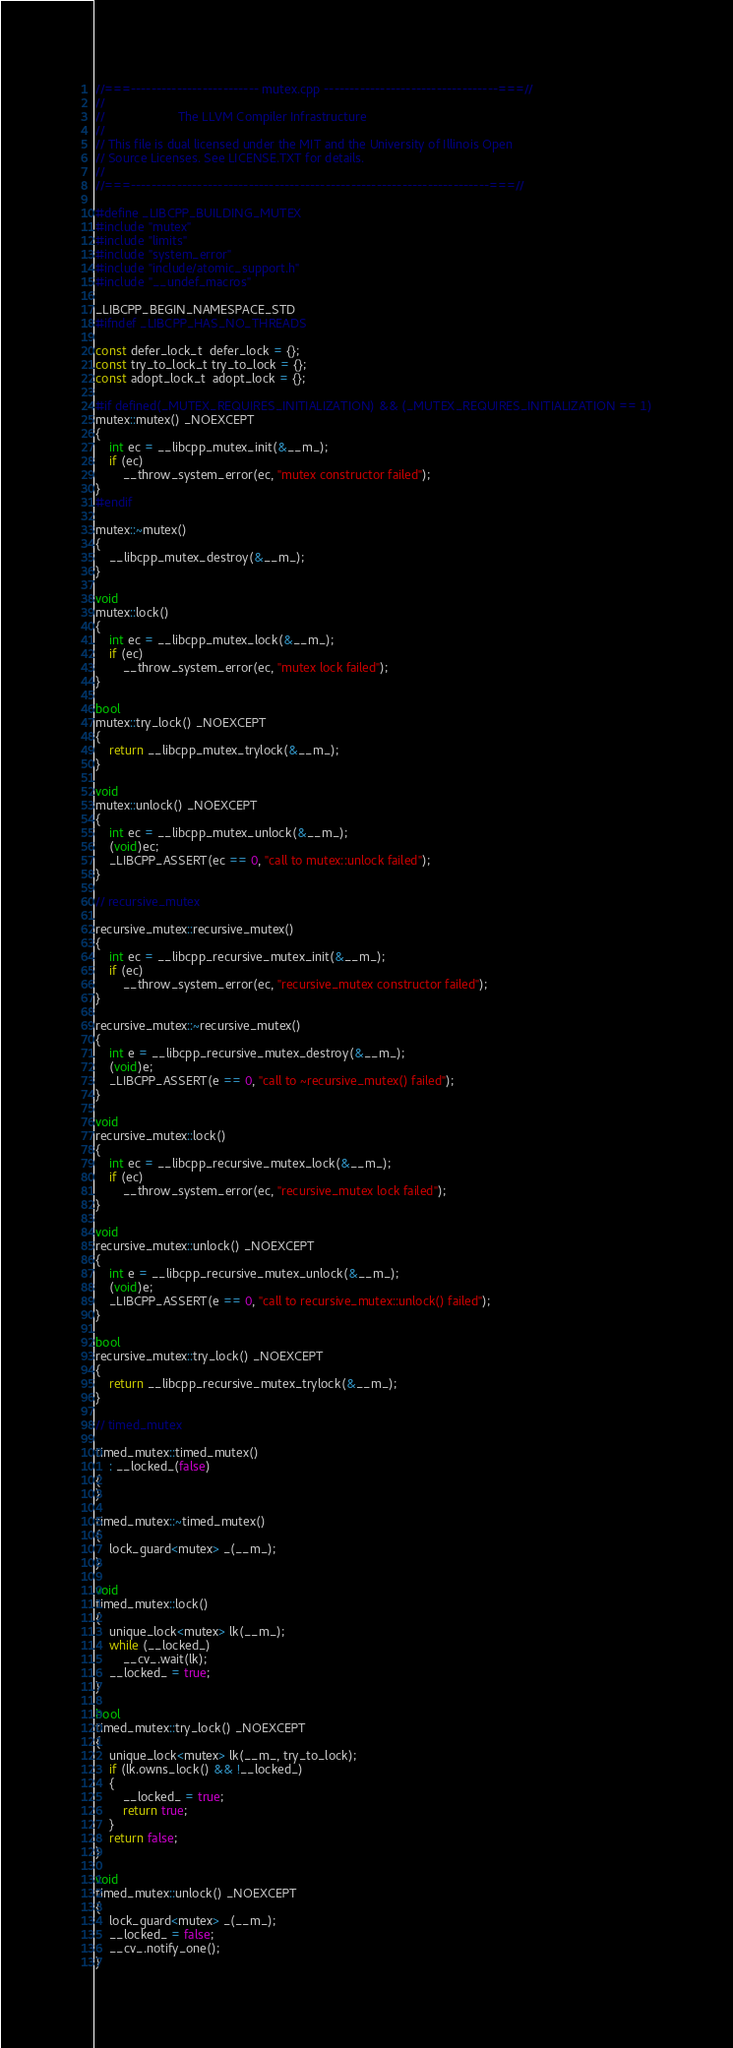<code> <loc_0><loc_0><loc_500><loc_500><_C++_>//===------------------------- mutex.cpp ----------------------------------===//
//
//                     The LLVM Compiler Infrastructure
//
// This file is dual licensed under the MIT and the University of Illinois Open
// Source Licenses. See LICENSE.TXT for details.
//
//===----------------------------------------------------------------------===//

#define _LIBCPP_BUILDING_MUTEX
#include "mutex"
#include "limits"
#include "system_error"
#include "include/atomic_support.h"
#include "__undef_macros"

_LIBCPP_BEGIN_NAMESPACE_STD
#ifndef _LIBCPP_HAS_NO_THREADS

const defer_lock_t  defer_lock = {};
const try_to_lock_t try_to_lock = {};
const adopt_lock_t  adopt_lock = {};

#if defined(_MUTEX_REQUIRES_INITIALIZATION) && (_MUTEX_REQUIRES_INITIALIZATION == 1)
mutex::mutex() _NOEXCEPT
{
	int ec = __libcpp_mutex_init(&__m_);
    if (ec)
        __throw_system_error(ec, "mutex constructor failed");
}
#endif

mutex::~mutex()
{
    __libcpp_mutex_destroy(&__m_);
}

void
mutex::lock()
{
    int ec = __libcpp_mutex_lock(&__m_);
    if (ec)
        __throw_system_error(ec, "mutex lock failed");
}

bool
mutex::try_lock() _NOEXCEPT
{
    return __libcpp_mutex_trylock(&__m_);
}

void
mutex::unlock() _NOEXCEPT
{
    int ec = __libcpp_mutex_unlock(&__m_);
    (void)ec;
    _LIBCPP_ASSERT(ec == 0, "call to mutex::unlock failed");
}

// recursive_mutex

recursive_mutex::recursive_mutex()
{
    int ec = __libcpp_recursive_mutex_init(&__m_);
    if (ec)
        __throw_system_error(ec, "recursive_mutex constructor failed");
}

recursive_mutex::~recursive_mutex()
{
    int e = __libcpp_recursive_mutex_destroy(&__m_);
    (void)e;
    _LIBCPP_ASSERT(e == 0, "call to ~recursive_mutex() failed");
}

void
recursive_mutex::lock()
{
    int ec = __libcpp_recursive_mutex_lock(&__m_);
    if (ec)
        __throw_system_error(ec, "recursive_mutex lock failed");
}

void
recursive_mutex::unlock() _NOEXCEPT
{
    int e = __libcpp_recursive_mutex_unlock(&__m_);
    (void)e;
    _LIBCPP_ASSERT(e == 0, "call to recursive_mutex::unlock() failed");
}

bool
recursive_mutex::try_lock() _NOEXCEPT
{
    return __libcpp_recursive_mutex_trylock(&__m_);
}

// timed_mutex

timed_mutex::timed_mutex()
    : __locked_(false)
{
}

timed_mutex::~timed_mutex()
{
    lock_guard<mutex> _(__m_);
}

void
timed_mutex::lock()
{
    unique_lock<mutex> lk(__m_);
    while (__locked_)
        __cv_.wait(lk);
    __locked_ = true;
}

bool
timed_mutex::try_lock() _NOEXCEPT
{
    unique_lock<mutex> lk(__m_, try_to_lock);
    if (lk.owns_lock() && !__locked_)
    {
        __locked_ = true;
        return true;
    }
    return false;
}

void
timed_mutex::unlock() _NOEXCEPT
{
    lock_guard<mutex> _(__m_);
    __locked_ = false;
    __cv_.notify_one();
}
</code> 